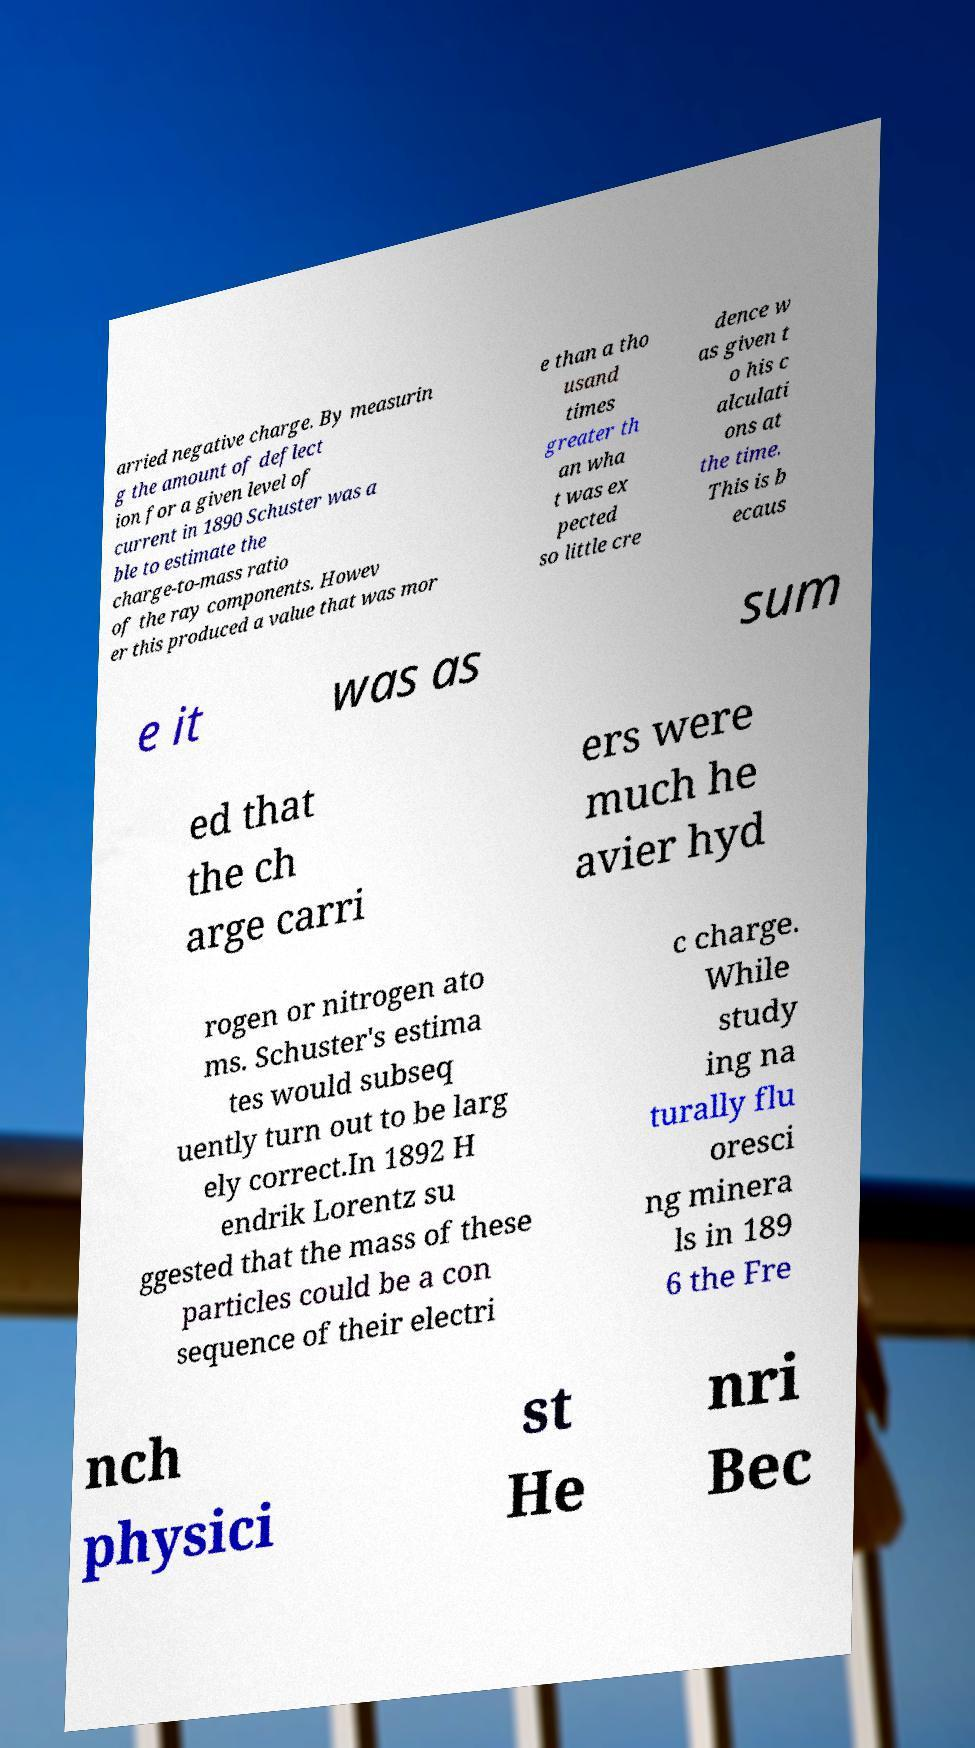Could you extract and type out the text from this image? arried negative charge. By measurin g the amount of deflect ion for a given level of current in 1890 Schuster was a ble to estimate the charge-to-mass ratio of the ray components. Howev er this produced a value that was mor e than a tho usand times greater th an wha t was ex pected so little cre dence w as given t o his c alculati ons at the time. This is b ecaus e it was as sum ed that the ch arge carri ers were much he avier hyd rogen or nitrogen ato ms. Schuster's estima tes would subseq uently turn out to be larg ely correct.In 1892 H endrik Lorentz su ggested that the mass of these particles could be a con sequence of their electri c charge. While study ing na turally flu oresci ng minera ls in 189 6 the Fre nch physici st He nri Bec 